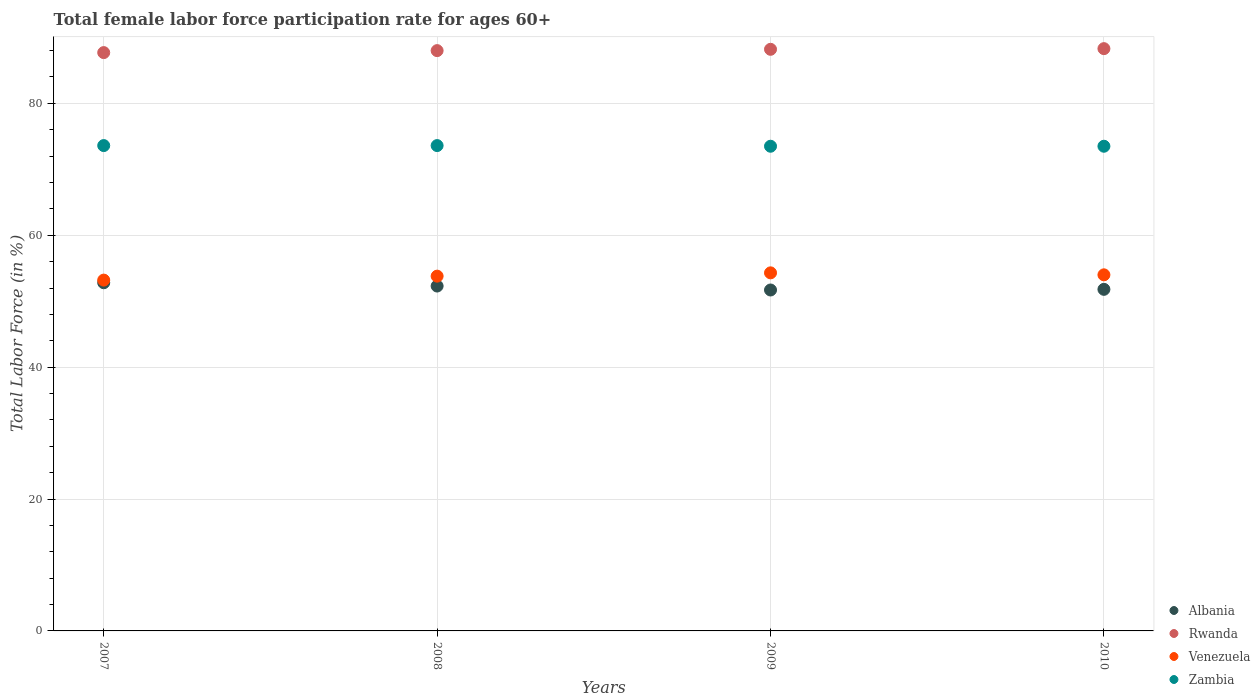How many different coloured dotlines are there?
Provide a short and direct response. 4. What is the female labor force participation rate in Venezuela in 2009?
Give a very brief answer. 54.3. Across all years, what is the maximum female labor force participation rate in Venezuela?
Offer a very short reply. 54.3. Across all years, what is the minimum female labor force participation rate in Zambia?
Offer a terse response. 73.5. In which year was the female labor force participation rate in Venezuela minimum?
Your response must be concise. 2007. What is the total female labor force participation rate in Rwanda in the graph?
Provide a succinct answer. 352.2. What is the difference between the female labor force participation rate in Rwanda in 2009 and that in 2010?
Give a very brief answer. -0.1. What is the difference between the female labor force participation rate in Venezuela in 2010 and the female labor force participation rate in Rwanda in 2008?
Provide a succinct answer. -34. What is the average female labor force participation rate in Rwanda per year?
Provide a short and direct response. 88.05. In the year 2009, what is the difference between the female labor force participation rate in Zambia and female labor force participation rate in Venezuela?
Keep it short and to the point. 19.2. In how many years, is the female labor force participation rate in Venezuela greater than 20 %?
Make the answer very short. 4. What is the ratio of the female labor force participation rate in Rwanda in 2007 to that in 2009?
Offer a very short reply. 0.99. Is the female labor force participation rate in Zambia in 2007 less than that in 2009?
Your answer should be very brief. No. Is the difference between the female labor force participation rate in Zambia in 2007 and 2010 greater than the difference between the female labor force participation rate in Venezuela in 2007 and 2010?
Keep it short and to the point. Yes. What is the difference between the highest and the second highest female labor force participation rate in Venezuela?
Give a very brief answer. 0.3. What is the difference between the highest and the lowest female labor force participation rate in Zambia?
Provide a succinct answer. 0.1. In how many years, is the female labor force participation rate in Albania greater than the average female labor force participation rate in Albania taken over all years?
Provide a short and direct response. 2. Is the female labor force participation rate in Albania strictly greater than the female labor force participation rate in Venezuela over the years?
Give a very brief answer. No. Is the female labor force participation rate in Albania strictly less than the female labor force participation rate in Venezuela over the years?
Keep it short and to the point. Yes. How many dotlines are there?
Your response must be concise. 4. How many years are there in the graph?
Your answer should be very brief. 4. Does the graph contain grids?
Your answer should be very brief. Yes. Where does the legend appear in the graph?
Offer a terse response. Bottom right. How many legend labels are there?
Your answer should be very brief. 4. How are the legend labels stacked?
Offer a very short reply. Vertical. What is the title of the graph?
Provide a succinct answer. Total female labor force participation rate for ages 60+. Does "Europe(all income levels)" appear as one of the legend labels in the graph?
Your response must be concise. No. What is the label or title of the Y-axis?
Ensure brevity in your answer.  Total Labor Force (in %). What is the Total Labor Force (in %) of Albania in 2007?
Your response must be concise. 52.8. What is the Total Labor Force (in %) in Rwanda in 2007?
Give a very brief answer. 87.7. What is the Total Labor Force (in %) of Venezuela in 2007?
Offer a terse response. 53.2. What is the Total Labor Force (in %) of Zambia in 2007?
Provide a short and direct response. 73.6. What is the Total Labor Force (in %) of Albania in 2008?
Provide a short and direct response. 52.3. What is the Total Labor Force (in %) in Venezuela in 2008?
Provide a short and direct response. 53.8. What is the Total Labor Force (in %) in Zambia in 2008?
Your answer should be very brief. 73.6. What is the Total Labor Force (in %) in Albania in 2009?
Provide a short and direct response. 51.7. What is the Total Labor Force (in %) of Rwanda in 2009?
Offer a terse response. 88.2. What is the Total Labor Force (in %) of Venezuela in 2009?
Keep it short and to the point. 54.3. What is the Total Labor Force (in %) of Zambia in 2009?
Your response must be concise. 73.5. What is the Total Labor Force (in %) in Albania in 2010?
Keep it short and to the point. 51.8. What is the Total Labor Force (in %) in Rwanda in 2010?
Your answer should be compact. 88.3. What is the Total Labor Force (in %) in Zambia in 2010?
Your response must be concise. 73.5. Across all years, what is the maximum Total Labor Force (in %) of Albania?
Your response must be concise. 52.8. Across all years, what is the maximum Total Labor Force (in %) of Rwanda?
Offer a terse response. 88.3. Across all years, what is the maximum Total Labor Force (in %) of Venezuela?
Make the answer very short. 54.3. Across all years, what is the maximum Total Labor Force (in %) of Zambia?
Give a very brief answer. 73.6. Across all years, what is the minimum Total Labor Force (in %) of Albania?
Your answer should be compact. 51.7. Across all years, what is the minimum Total Labor Force (in %) of Rwanda?
Provide a short and direct response. 87.7. Across all years, what is the minimum Total Labor Force (in %) of Venezuela?
Keep it short and to the point. 53.2. Across all years, what is the minimum Total Labor Force (in %) of Zambia?
Offer a terse response. 73.5. What is the total Total Labor Force (in %) in Albania in the graph?
Provide a succinct answer. 208.6. What is the total Total Labor Force (in %) in Rwanda in the graph?
Your response must be concise. 352.2. What is the total Total Labor Force (in %) in Venezuela in the graph?
Ensure brevity in your answer.  215.3. What is the total Total Labor Force (in %) of Zambia in the graph?
Make the answer very short. 294.2. What is the difference between the Total Labor Force (in %) in Rwanda in 2007 and that in 2008?
Offer a very short reply. -0.3. What is the difference between the Total Labor Force (in %) in Venezuela in 2007 and that in 2009?
Provide a succinct answer. -1.1. What is the difference between the Total Labor Force (in %) in Albania in 2007 and that in 2010?
Keep it short and to the point. 1. What is the difference between the Total Labor Force (in %) in Rwanda in 2007 and that in 2010?
Your answer should be compact. -0.6. What is the difference between the Total Labor Force (in %) in Venezuela in 2007 and that in 2010?
Make the answer very short. -0.8. What is the difference between the Total Labor Force (in %) of Zambia in 2007 and that in 2010?
Provide a short and direct response. 0.1. What is the difference between the Total Labor Force (in %) of Rwanda in 2008 and that in 2009?
Keep it short and to the point. -0.2. What is the difference between the Total Labor Force (in %) in Venezuela in 2008 and that in 2009?
Provide a short and direct response. -0.5. What is the difference between the Total Labor Force (in %) in Zambia in 2008 and that in 2009?
Your answer should be very brief. 0.1. What is the difference between the Total Labor Force (in %) of Albania in 2008 and that in 2010?
Give a very brief answer. 0.5. What is the difference between the Total Labor Force (in %) of Venezuela in 2008 and that in 2010?
Your answer should be very brief. -0.2. What is the difference between the Total Labor Force (in %) of Albania in 2009 and that in 2010?
Offer a very short reply. -0.1. What is the difference between the Total Labor Force (in %) in Venezuela in 2009 and that in 2010?
Provide a short and direct response. 0.3. What is the difference between the Total Labor Force (in %) of Zambia in 2009 and that in 2010?
Your answer should be compact. 0. What is the difference between the Total Labor Force (in %) in Albania in 2007 and the Total Labor Force (in %) in Rwanda in 2008?
Your response must be concise. -35.2. What is the difference between the Total Labor Force (in %) in Albania in 2007 and the Total Labor Force (in %) in Zambia in 2008?
Provide a succinct answer. -20.8. What is the difference between the Total Labor Force (in %) in Rwanda in 2007 and the Total Labor Force (in %) in Venezuela in 2008?
Your answer should be compact. 33.9. What is the difference between the Total Labor Force (in %) of Rwanda in 2007 and the Total Labor Force (in %) of Zambia in 2008?
Offer a terse response. 14.1. What is the difference between the Total Labor Force (in %) of Venezuela in 2007 and the Total Labor Force (in %) of Zambia in 2008?
Provide a succinct answer. -20.4. What is the difference between the Total Labor Force (in %) of Albania in 2007 and the Total Labor Force (in %) of Rwanda in 2009?
Your answer should be compact. -35.4. What is the difference between the Total Labor Force (in %) in Albania in 2007 and the Total Labor Force (in %) in Zambia in 2009?
Provide a short and direct response. -20.7. What is the difference between the Total Labor Force (in %) of Rwanda in 2007 and the Total Labor Force (in %) of Venezuela in 2009?
Your answer should be very brief. 33.4. What is the difference between the Total Labor Force (in %) of Venezuela in 2007 and the Total Labor Force (in %) of Zambia in 2009?
Provide a succinct answer. -20.3. What is the difference between the Total Labor Force (in %) of Albania in 2007 and the Total Labor Force (in %) of Rwanda in 2010?
Provide a short and direct response. -35.5. What is the difference between the Total Labor Force (in %) of Albania in 2007 and the Total Labor Force (in %) of Zambia in 2010?
Make the answer very short. -20.7. What is the difference between the Total Labor Force (in %) in Rwanda in 2007 and the Total Labor Force (in %) in Venezuela in 2010?
Offer a very short reply. 33.7. What is the difference between the Total Labor Force (in %) of Rwanda in 2007 and the Total Labor Force (in %) of Zambia in 2010?
Your answer should be very brief. 14.2. What is the difference between the Total Labor Force (in %) in Venezuela in 2007 and the Total Labor Force (in %) in Zambia in 2010?
Your response must be concise. -20.3. What is the difference between the Total Labor Force (in %) in Albania in 2008 and the Total Labor Force (in %) in Rwanda in 2009?
Offer a very short reply. -35.9. What is the difference between the Total Labor Force (in %) in Albania in 2008 and the Total Labor Force (in %) in Zambia in 2009?
Make the answer very short. -21.2. What is the difference between the Total Labor Force (in %) of Rwanda in 2008 and the Total Labor Force (in %) of Venezuela in 2009?
Your answer should be compact. 33.7. What is the difference between the Total Labor Force (in %) of Venezuela in 2008 and the Total Labor Force (in %) of Zambia in 2009?
Your answer should be compact. -19.7. What is the difference between the Total Labor Force (in %) in Albania in 2008 and the Total Labor Force (in %) in Rwanda in 2010?
Provide a short and direct response. -36. What is the difference between the Total Labor Force (in %) of Albania in 2008 and the Total Labor Force (in %) of Zambia in 2010?
Give a very brief answer. -21.2. What is the difference between the Total Labor Force (in %) of Rwanda in 2008 and the Total Labor Force (in %) of Zambia in 2010?
Ensure brevity in your answer.  14.5. What is the difference between the Total Labor Force (in %) of Venezuela in 2008 and the Total Labor Force (in %) of Zambia in 2010?
Your answer should be very brief. -19.7. What is the difference between the Total Labor Force (in %) of Albania in 2009 and the Total Labor Force (in %) of Rwanda in 2010?
Your answer should be very brief. -36.6. What is the difference between the Total Labor Force (in %) of Albania in 2009 and the Total Labor Force (in %) of Zambia in 2010?
Your answer should be very brief. -21.8. What is the difference between the Total Labor Force (in %) of Rwanda in 2009 and the Total Labor Force (in %) of Venezuela in 2010?
Offer a very short reply. 34.2. What is the difference between the Total Labor Force (in %) in Venezuela in 2009 and the Total Labor Force (in %) in Zambia in 2010?
Ensure brevity in your answer.  -19.2. What is the average Total Labor Force (in %) of Albania per year?
Make the answer very short. 52.15. What is the average Total Labor Force (in %) of Rwanda per year?
Your answer should be very brief. 88.05. What is the average Total Labor Force (in %) in Venezuela per year?
Make the answer very short. 53.83. What is the average Total Labor Force (in %) in Zambia per year?
Your answer should be compact. 73.55. In the year 2007, what is the difference between the Total Labor Force (in %) in Albania and Total Labor Force (in %) in Rwanda?
Keep it short and to the point. -34.9. In the year 2007, what is the difference between the Total Labor Force (in %) of Albania and Total Labor Force (in %) of Venezuela?
Give a very brief answer. -0.4. In the year 2007, what is the difference between the Total Labor Force (in %) in Albania and Total Labor Force (in %) in Zambia?
Give a very brief answer. -20.8. In the year 2007, what is the difference between the Total Labor Force (in %) of Rwanda and Total Labor Force (in %) of Venezuela?
Offer a very short reply. 34.5. In the year 2007, what is the difference between the Total Labor Force (in %) of Venezuela and Total Labor Force (in %) of Zambia?
Ensure brevity in your answer.  -20.4. In the year 2008, what is the difference between the Total Labor Force (in %) of Albania and Total Labor Force (in %) of Rwanda?
Offer a very short reply. -35.7. In the year 2008, what is the difference between the Total Labor Force (in %) of Albania and Total Labor Force (in %) of Venezuela?
Your answer should be compact. -1.5. In the year 2008, what is the difference between the Total Labor Force (in %) in Albania and Total Labor Force (in %) in Zambia?
Make the answer very short. -21.3. In the year 2008, what is the difference between the Total Labor Force (in %) of Rwanda and Total Labor Force (in %) of Venezuela?
Offer a terse response. 34.2. In the year 2008, what is the difference between the Total Labor Force (in %) of Rwanda and Total Labor Force (in %) of Zambia?
Keep it short and to the point. 14.4. In the year 2008, what is the difference between the Total Labor Force (in %) in Venezuela and Total Labor Force (in %) in Zambia?
Provide a short and direct response. -19.8. In the year 2009, what is the difference between the Total Labor Force (in %) of Albania and Total Labor Force (in %) of Rwanda?
Offer a terse response. -36.5. In the year 2009, what is the difference between the Total Labor Force (in %) in Albania and Total Labor Force (in %) in Venezuela?
Your answer should be compact. -2.6. In the year 2009, what is the difference between the Total Labor Force (in %) of Albania and Total Labor Force (in %) of Zambia?
Your response must be concise. -21.8. In the year 2009, what is the difference between the Total Labor Force (in %) of Rwanda and Total Labor Force (in %) of Venezuela?
Give a very brief answer. 33.9. In the year 2009, what is the difference between the Total Labor Force (in %) in Venezuela and Total Labor Force (in %) in Zambia?
Keep it short and to the point. -19.2. In the year 2010, what is the difference between the Total Labor Force (in %) of Albania and Total Labor Force (in %) of Rwanda?
Your answer should be compact. -36.5. In the year 2010, what is the difference between the Total Labor Force (in %) of Albania and Total Labor Force (in %) of Zambia?
Make the answer very short. -21.7. In the year 2010, what is the difference between the Total Labor Force (in %) of Rwanda and Total Labor Force (in %) of Venezuela?
Offer a very short reply. 34.3. In the year 2010, what is the difference between the Total Labor Force (in %) of Rwanda and Total Labor Force (in %) of Zambia?
Provide a short and direct response. 14.8. In the year 2010, what is the difference between the Total Labor Force (in %) of Venezuela and Total Labor Force (in %) of Zambia?
Your response must be concise. -19.5. What is the ratio of the Total Labor Force (in %) of Albania in 2007 to that in 2008?
Provide a succinct answer. 1.01. What is the ratio of the Total Labor Force (in %) in Rwanda in 2007 to that in 2008?
Offer a very short reply. 1. What is the ratio of the Total Labor Force (in %) of Venezuela in 2007 to that in 2008?
Your response must be concise. 0.99. What is the ratio of the Total Labor Force (in %) in Albania in 2007 to that in 2009?
Your answer should be compact. 1.02. What is the ratio of the Total Labor Force (in %) of Rwanda in 2007 to that in 2009?
Your answer should be very brief. 0.99. What is the ratio of the Total Labor Force (in %) in Venezuela in 2007 to that in 2009?
Offer a terse response. 0.98. What is the ratio of the Total Labor Force (in %) in Albania in 2007 to that in 2010?
Keep it short and to the point. 1.02. What is the ratio of the Total Labor Force (in %) of Venezuela in 2007 to that in 2010?
Your answer should be compact. 0.99. What is the ratio of the Total Labor Force (in %) of Albania in 2008 to that in 2009?
Your answer should be compact. 1.01. What is the ratio of the Total Labor Force (in %) of Rwanda in 2008 to that in 2009?
Provide a succinct answer. 1. What is the ratio of the Total Labor Force (in %) in Albania in 2008 to that in 2010?
Your answer should be compact. 1.01. What is the ratio of the Total Labor Force (in %) of Venezuela in 2008 to that in 2010?
Provide a succinct answer. 1. What is the ratio of the Total Labor Force (in %) of Zambia in 2008 to that in 2010?
Your answer should be very brief. 1. What is the ratio of the Total Labor Force (in %) of Venezuela in 2009 to that in 2010?
Ensure brevity in your answer.  1.01. What is the difference between the highest and the second highest Total Labor Force (in %) of Albania?
Offer a very short reply. 0.5. What is the difference between the highest and the lowest Total Labor Force (in %) of Rwanda?
Provide a short and direct response. 0.6. 